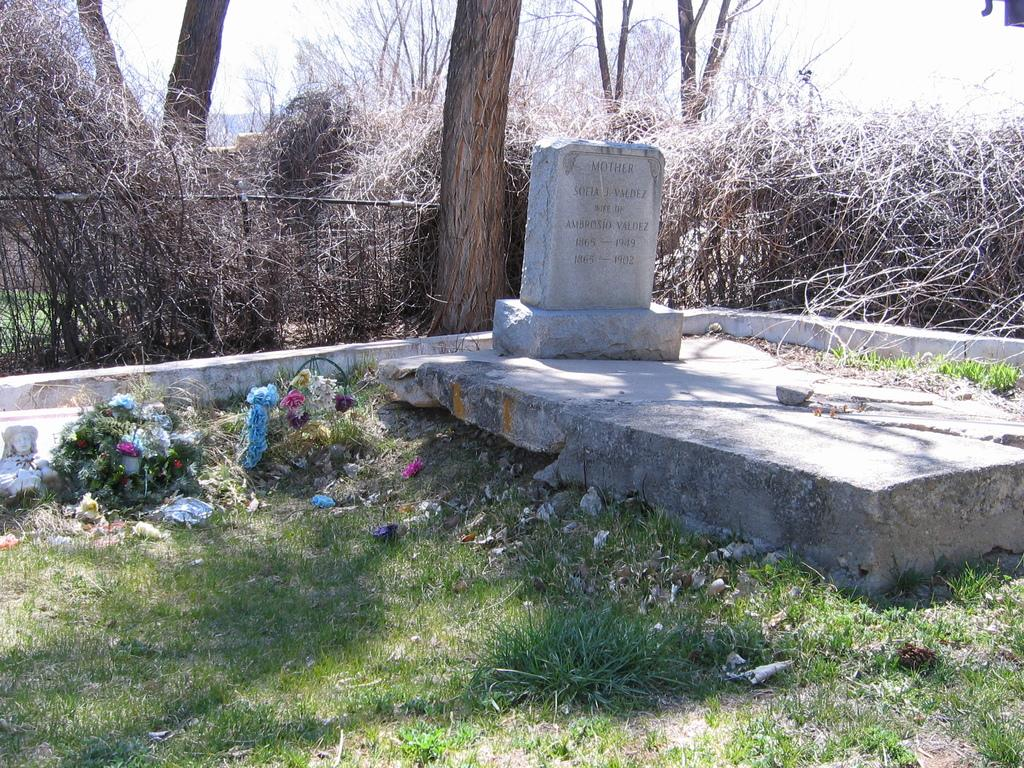What is the main object in the image? There is a headstone in the image. What type of vegetation can be seen in the image? Grass, plants, and trees are present in the image. What is the material of the grilles behind the headstone? Iron grilles are visible behind the headstone. What can be seen in the background of the image? Trees and the sky are visible in the background of the image. What book is the person reading in the image? There is no person or book visible in the image; it features a headstone and surrounding elements. Can you describe the beetle crawling on the headstone in the image? There is no beetle present on the headstone in the image. 